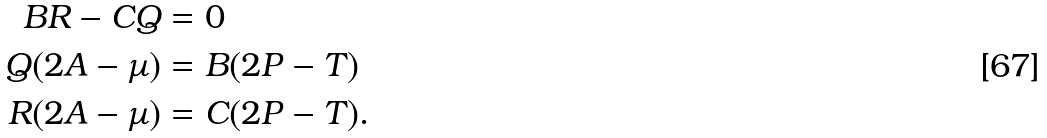<formula> <loc_0><loc_0><loc_500><loc_500>B R - C Q & = 0 \\ Q ( 2 A - \mu ) & = B ( 2 P - T ) \\ R ( 2 A - \mu ) & = C ( 2 P - T ) .</formula> 